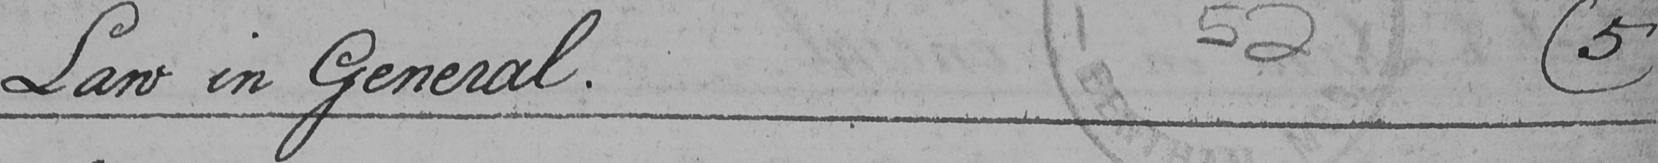Can you tell me what this handwritten text says? Law in General .  ( 5 